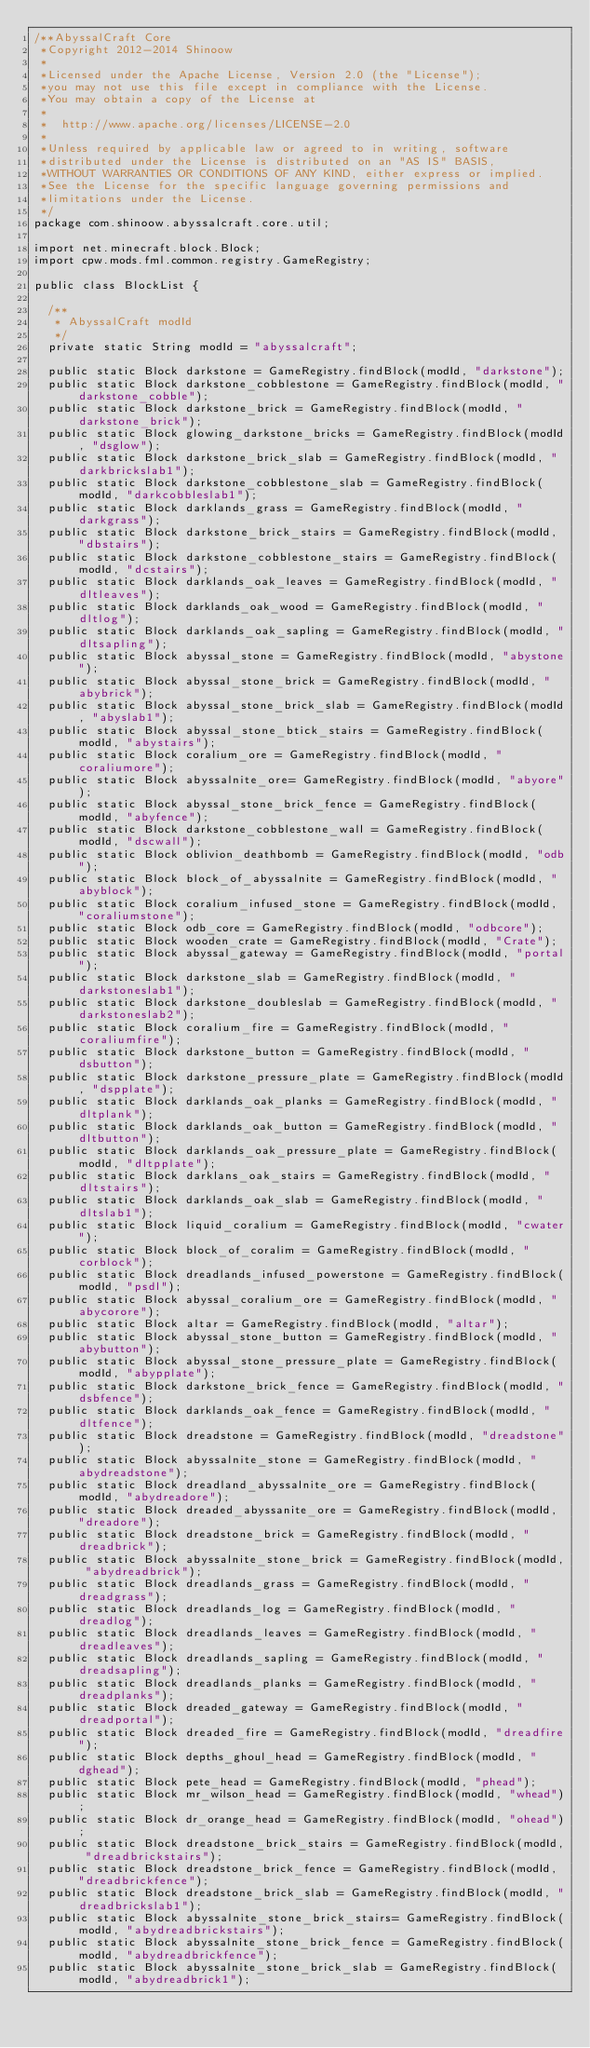<code> <loc_0><loc_0><loc_500><loc_500><_Java_>/**AbyssalCraft Core
 *Copyright 2012-2014 Shinoow
 *
 *Licensed under the Apache License, Version 2.0 (the "License");
 *you may not use this file except in compliance with the License.
 *You may obtain a copy of the License at
 *
 *  http://www.apache.org/licenses/LICENSE-2.0
 *
 *Unless required by applicable law or agreed to in writing, software
 *distributed under the License is distributed on an "AS IS" BASIS,
 *WITHOUT WARRANTIES OR CONDITIONS OF ANY KIND, either express or implied.
 *See the License for the specific language governing permissions and
 *limitations under the License.
 */
package com.shinoow.abyssalcraft.core.util;

import net.minecraft.block.Block;
import cpw.mods.fml.common.registry.GameRegistry;

public class BlockList {

	/**
	 * AbyssalCraft modId
	 */
	private static String modId = "abyssalcraft";

	public static Block darkstone = GameRegistry.findBlock(modId, "darkstone");
	public static Block darkstone_cobblestone = GameRegistry.findBlock(modId, "darkstone_cobble");
	public static Block darkstone_brick = GameRegistry.findBlock(modId, "darkstone_brick");
	public static Block glowing_darkstone_bricks = GameRegistry.findBlock(modId, "dsglow");
	public static Block darkstone_brick_slab = GameRegistry.findBlock(modId, "darkbrickslab1");
	public static Block darkstone_cobblestone_slab = GameRegistry.findBlock(modId, "darkcobbleslab1");
	public static Block darklands_grass = GameRegistry.findBlock(modId, "darkgrass");
	public static Block darkstone_brick_stairs = GameRegistry.findBlock(modId, "dbstairs");
	public static Block darkstone_cobblestone_stairs = GameRegistry.findBlock(modId, "dcstairs");
	public static Block darklands_oak_leaves = GameRegistry.findBlock(modId, "dltleaves");
	public static Block darklands_oak_wood = GameRegistry.findBlock(modId, "dltlog");
	public static Block darklands_oak_sapling = GameRegistry.findBlock(modId, "dltsapling");
	public static Block abyssal_stone = GameRegistry.findBlock(modId, "abystone");
	public static Block abyssal_stone_brick = GameRegistry.findBlock(modId, "abybrick");
	public static Block abyssal_stone_brick_slab = GameRegistry.findBlock(modId, "abyslab1");
	public static Block abyssal_stone_btick_stairs = GameRegistry.findBlock(modId, "abystairs");
	public static Block coralium_ore = GameRegistry.findBlock(modId, "coraliumore");
	public static Block abyssalnite_ore= GameRegistry.findBlock(modId, "abyore");
	public static Block abyssal_stone_brick_fence = GameRegistry.findBlock(modId, "abyfence");
	public static Block darkstone_cobblestone_wall = GameRegistry.findBlock(modId, "dscwall");
	public static Block oblivion_deathbomb = GameRegistry.findBlock(modId, "odb");
	public static Block block_of_abyssalnite = GameRegistry.findBlock(modId, "abyblock");
	public static Block coralium_infused_stone = GameRegistry.findBlock(modId, "coraliumstone");
	public static Block odb_core = GameRegistry.findBlock(modId, "odbcore");
	public static Block wooden_crate = GameRegistry.findBlock(modId, "Crate");
	public static Block abyssal_gateway = GameRegistry.findBlock(modId, "portal");
	public static Block darkstone_slab = GameRegistry.findBlock(modId, "darkstoneslab1");
	public static Block darkstone_doubleslab = GameRegistry.findBlock(modId, "darkstoneslab2");
	public static Block coralium_fire = GameRegistry.findBlock(modId, "coraliumfire");
	public static Block darkstone_button = GameRegistry.findBlock(modId, "dsbutton");
	public static Block darkstone_pressure_plate = GameRegistry.findBlock(modId, "dspplate");
	public static Block darklands_oak_planks = GameRegistry.findBlock(modId, "dltplank");
	public static Block darklands_oak_button = GameRegistry.findBlock(modId, "dltbutton");
	public static Block darklands_oak_pressure_plate = GameRegistry.findBlock(modId, "dltpplate");
	public static Block darklans_oak_stairs = GameRegistry.findBlock(modId, "dltstairs");
	public static Block darklands_oak_slab = GameRegistry.findBlock(modId, "dltslab1");
	public static Block liquid_coralium = GameRegistry.findBlock(modId, "cwater");
	public static Block block_of_coralim = GameRegistry.findBlock(modId, "corblock");
	public static Block dreadlands_infused_powerstone = GameRegistry.findBlock(modId, "psdl");
	public static Block abyssal_coralium_ore = GameRegistry.findBlock(modId, "abycorore");
	public static Block altar = GameRegistry.findBlock(modId, "altar");
	public static Block abyssal_stone_button = GameRegistry.findBlock(modId, "abybutton");
	public static Block abyssal_stone_pressure_plate = GameRegistry.findBlock(modId, "abypplate");
	public static Block darkstone_brick_fence = GameRegistry.findBlock(modId, "dsbfence");
	public static Block darklands_oak_fence = GameRegistry.findBlock(modId, "dltfence");
	public static Block dreadstone = GameRegistry.findBlock(modId, "dreadstone");
	public static Block abyssalnite_stone = GameRegistry.findBlock(modId, "abydreadstone");
	public static Block dreadland_abyssalnite_ore = GameRegistry.findBlock(modId, "abydreadore");
	public static Block dreaded_abyssanite_ore = GameRegistry.findBlock(modId, "dreadore");
	public static Block dreadstone_brick = GameRegistry.findBlock(modId, "dreadbrick");
	public static Block abyssalnite_stone_brick = GameRegistry.findBlock(modId, "abydreadbrick");
	public static Block dreadlands_grass = GameRegistry.findBlock(modId, "dreadgrass");
	public static Block dreadlands_log = GameRegistry.findBlock(modId, "dreadlog");
	public static Block dreadlands_leaves = GameRegistry.findBlock(modId, "dreadleaves");
	public static Block dreadlands_sapling = GameRegistry.findBlock(modId, "dreadsapling");
	public static Block dreadlands_planks = GameRegistry.findBlock(modId, "dreadplanks");
	public static Block dreaded_gateway = GameRegistry.findBlock(modId, "dreadportal");
	public static Block dreaded_fire = GameRegistry.findBlock(modId, "dreadfire");
	public static Block depths_ghoul_head = GameRegistry.findBlock(modId, "dghead");
	public static Block pete_head = GameRegistry.findBlock(modId, "phead");
	public static Block mr_wilson_head = GameRegistry.findBlock(modId, "whead");
	public static Block dr_orange_head = GameRegistry.findBlock(modId, "ohead");
	public static Block dreadstone_brick_stairs = GameRegistry.findBlock(modId, "dreadbrickstairs");
	public static Block dreadstone_brick_fence = GameRegistry.findBlock(modId, "dreadbrickfence");
	public static Block dreadstone_brick_slab = GameRegistry.findBlock(modId, "dreadbrickslab1");
	public static Block abyssalnite_stone_brick_stairs= GameRegistry.findBlock(modId, "abydreadbrickstairs");
	public static Block abyssalnite_stone_brick_fence = GameRegistry.findBlock(modId, "abydreadbrickfence");
	public static Block abyssalnite_stone_brick_slab = GameRegistry.findBlock(modId, "abydreadbrick1");</code> 